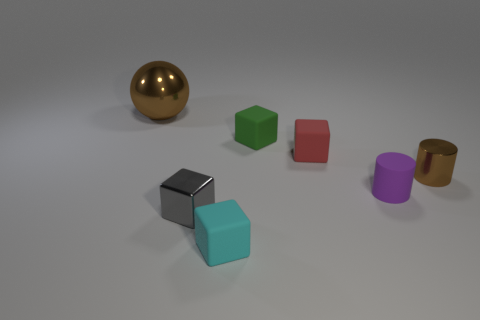Subtract all rubber blocks. How many blocks are left? 1 Subtract 2 blocks. How many blocks are left? 2 Add 3 cyan blocks. How many objects exist? 10 Subtract all purple cubes. Subtract all blue cylinders. How many cubes are left? 4 Subtract all cylinders. How many objects are left? 5 Add 5 purple rubber cylinders. How many purple rubber cylinders are left? 6 Add 7 tiny cyan blocks. How many tiny cyan blocks exist? 8 Subtract 1 purple cylinders. How many objects are left? 6 Subtract all purple rubber objects. Subtract all small cyan matte blocks. How many objects are left? 5 